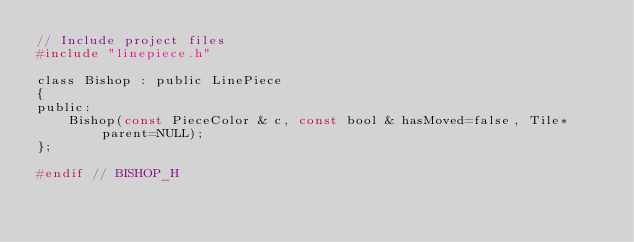Convert code to text. <code><loc_0><loc_0><loc_500><loc_500><_C_>// Include project files
#include "linepiece.h"

class Bishop : public LinePiece
{
public:
    Bishop(const PieceColor & c, const bool & hasMoved=false, Tile* parent=NULL);
};

#endif // BISHOP_H
</code> 